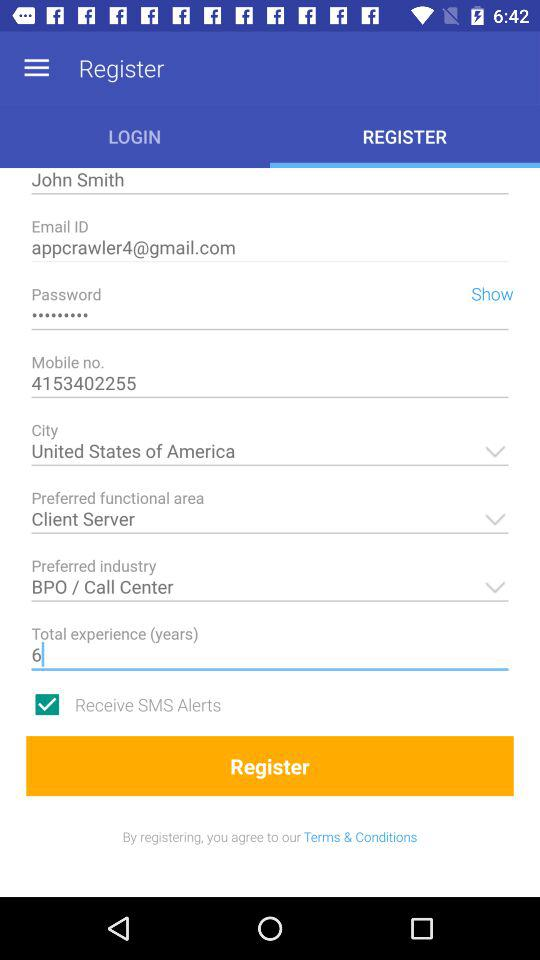Which is the preferred industry? The preferred industry is BPO/Call Center. 